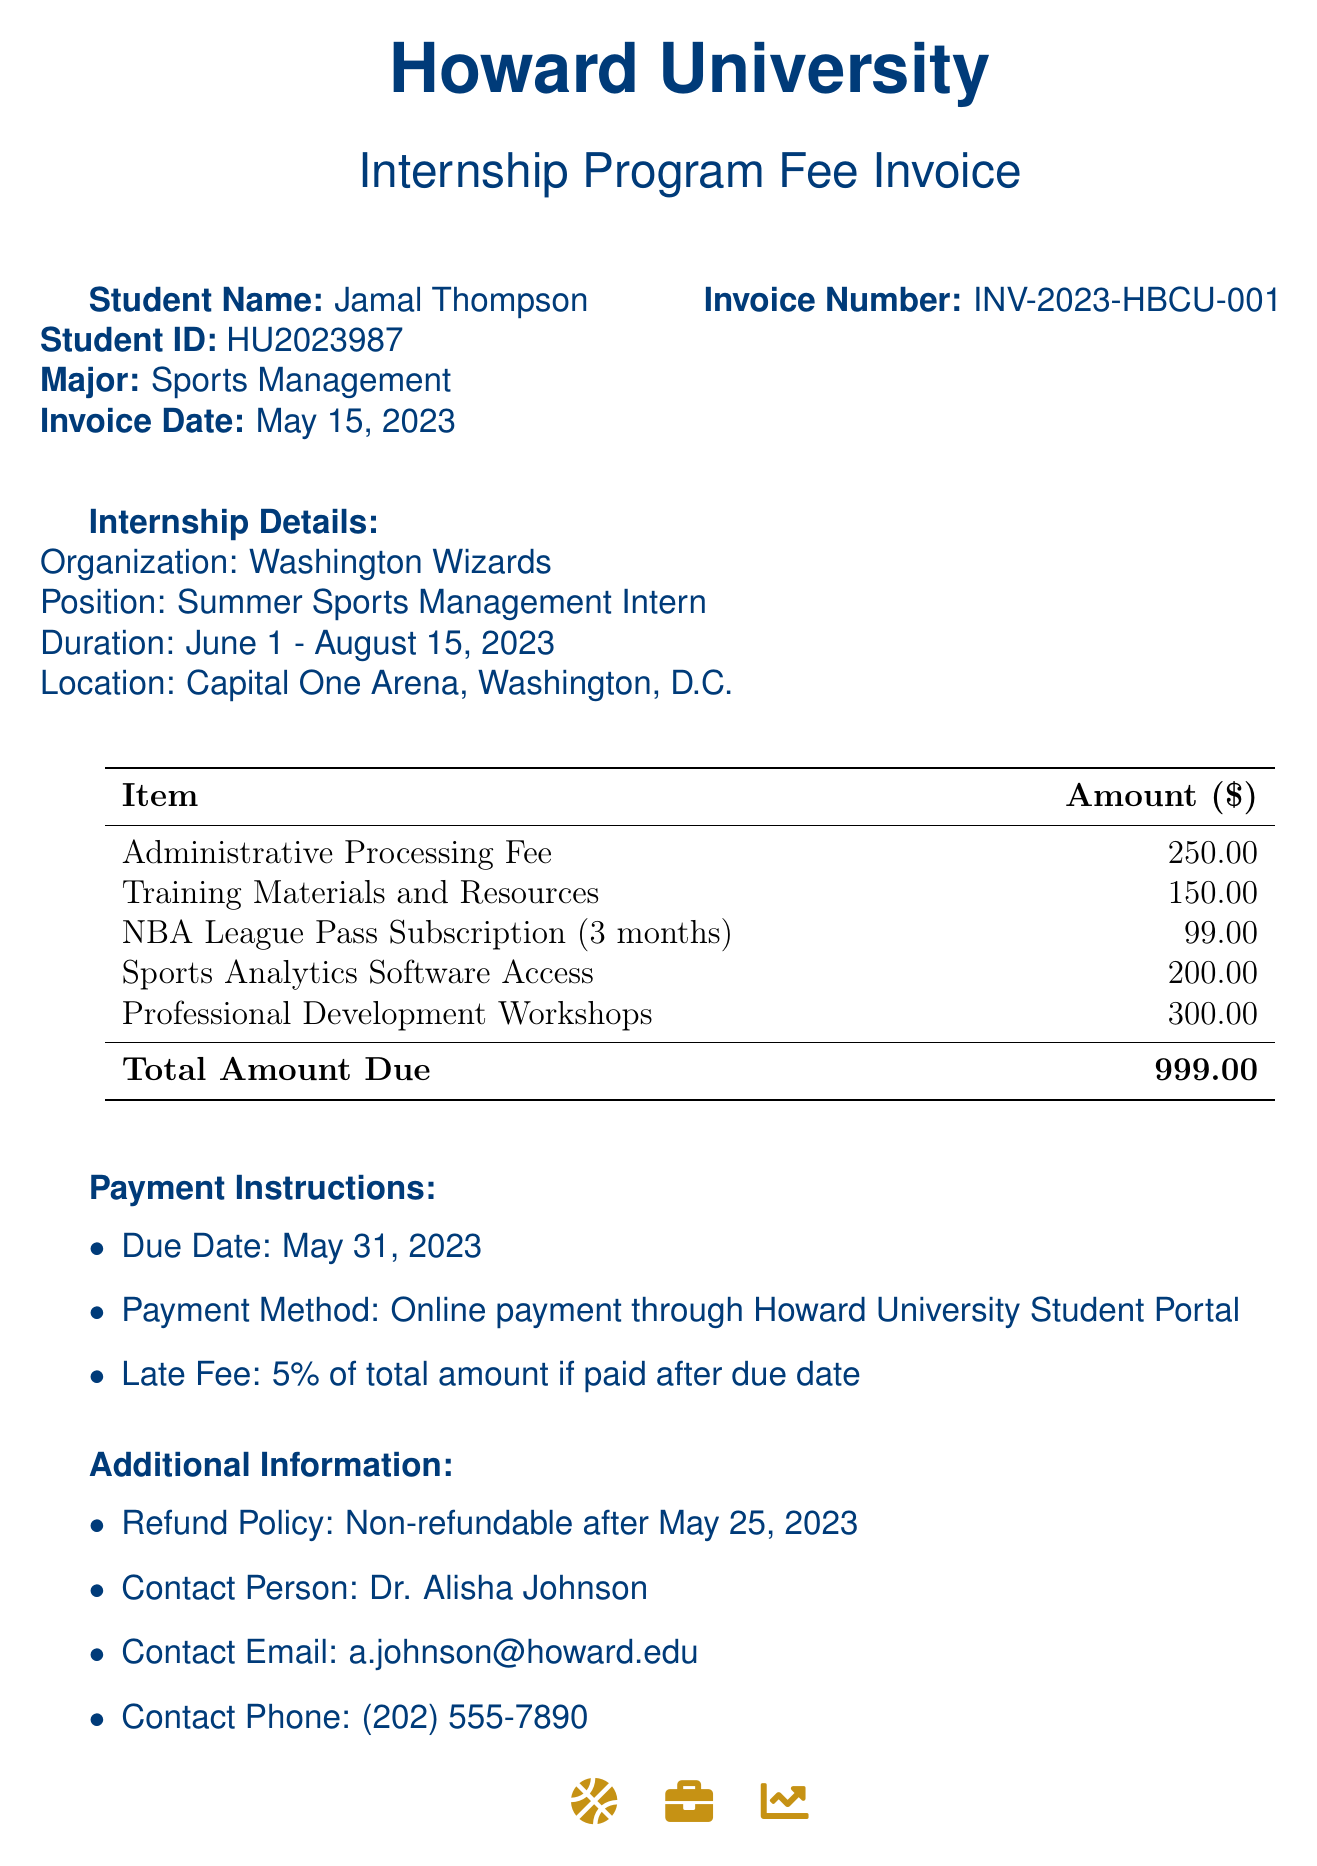What is the student’s name? The student’s name is listed at the beginning of the document under "Student Name."
Answer: Jamal Thompson What is the invoice date? The invoice date is found in the invoice section of the document, indicating when the invoice was issued.
Answer: May 15, 2023 How much is the total amount due? The total amount due is at the bottom of the invoice table summarizing the costs of the items.
Answer: 999.00 What organization is the internship with? The organization is specified under "Internship Details" where the internship position is mentioned.
Answer: Washington Wizards What is the duration of the internship? The duration is detailed in the "Internship Details” section indicating the start and end dates.
Answer: June 1 - August 15, 2023 What is the late fee percentage? The late fee percentage is stated in the "Payment Instructions" section of the document.
Answer: 5% Is the refund policy effective after May 25, 2023? The refund policy date is mentioned under "Additional Information," indicating when the refund policy becomes effective.
Answer: Non-refundable after May 25, 2023 Who is the contact person for the internship program? The contact person is specified in the "Additional Information" section of the document.
Answer: Dr. Alisha Johnson What payment method should be used? The payment method is mentioned in the "Payment Instructions" section indicating how payment should be processed.
Answer: Online payment through Howard University Student Portal 